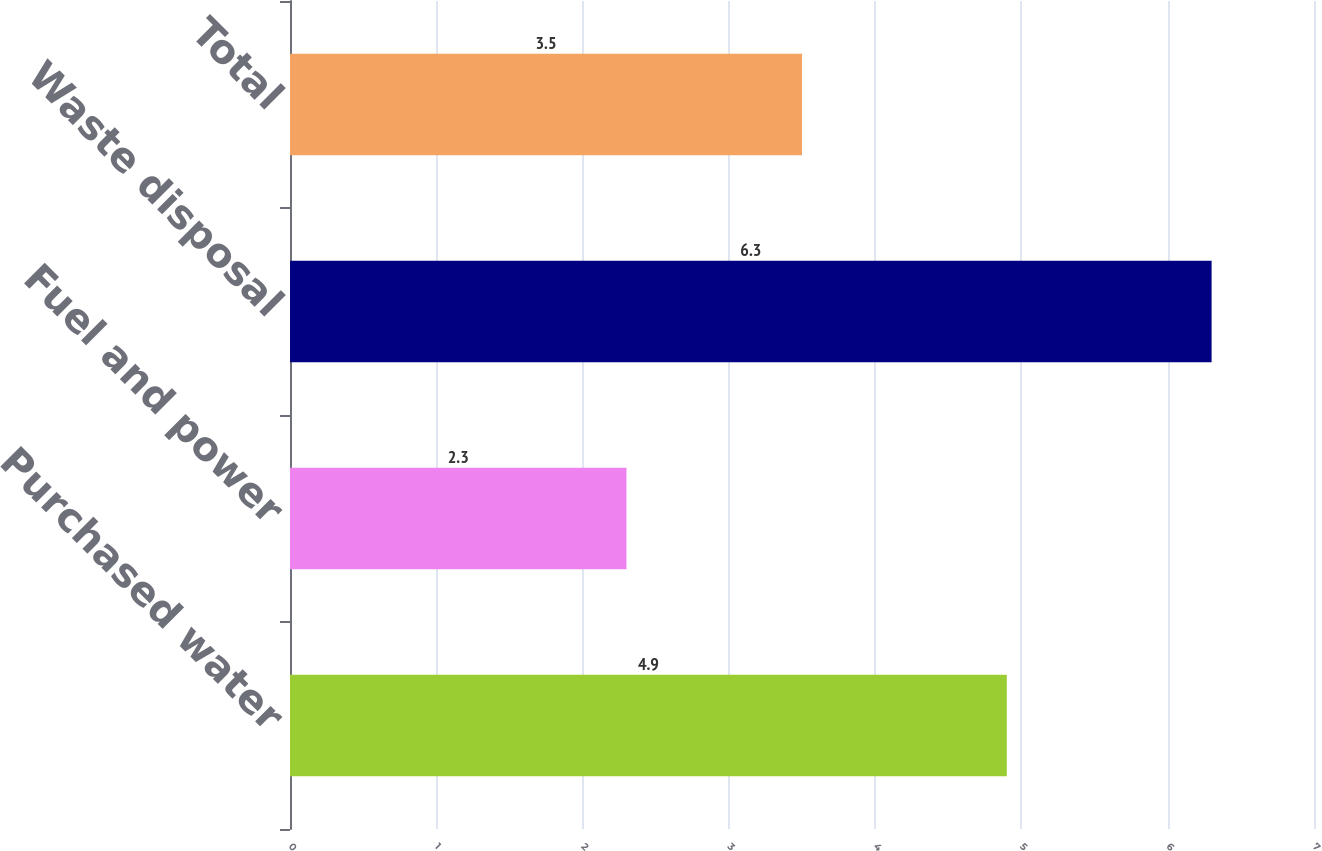Convert chart to OTSL. <chart><loc_0><loc_0><loc_500><loc_500><bar_chart><fcel>Purchased water<fcel>Fuel and power<fcel>Waste disposal<fcel>Total<nl><fcel>4.9<fcel>2.3<fcel>6.3<fcel>3.5<nl></chart> 